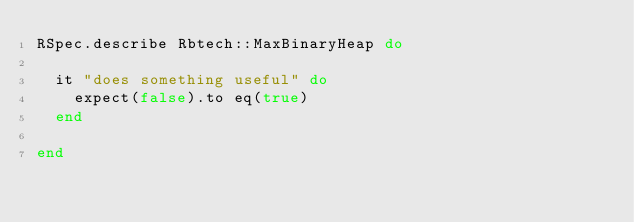<code> <loc_0><loc_0><loc_500><loc_500><_Ruby_>RSpec.describe Rbtech::MaxBinaryHeap do 

  it "does something useful" do
    expect(false).to eq(true)
  end

end

</code> 